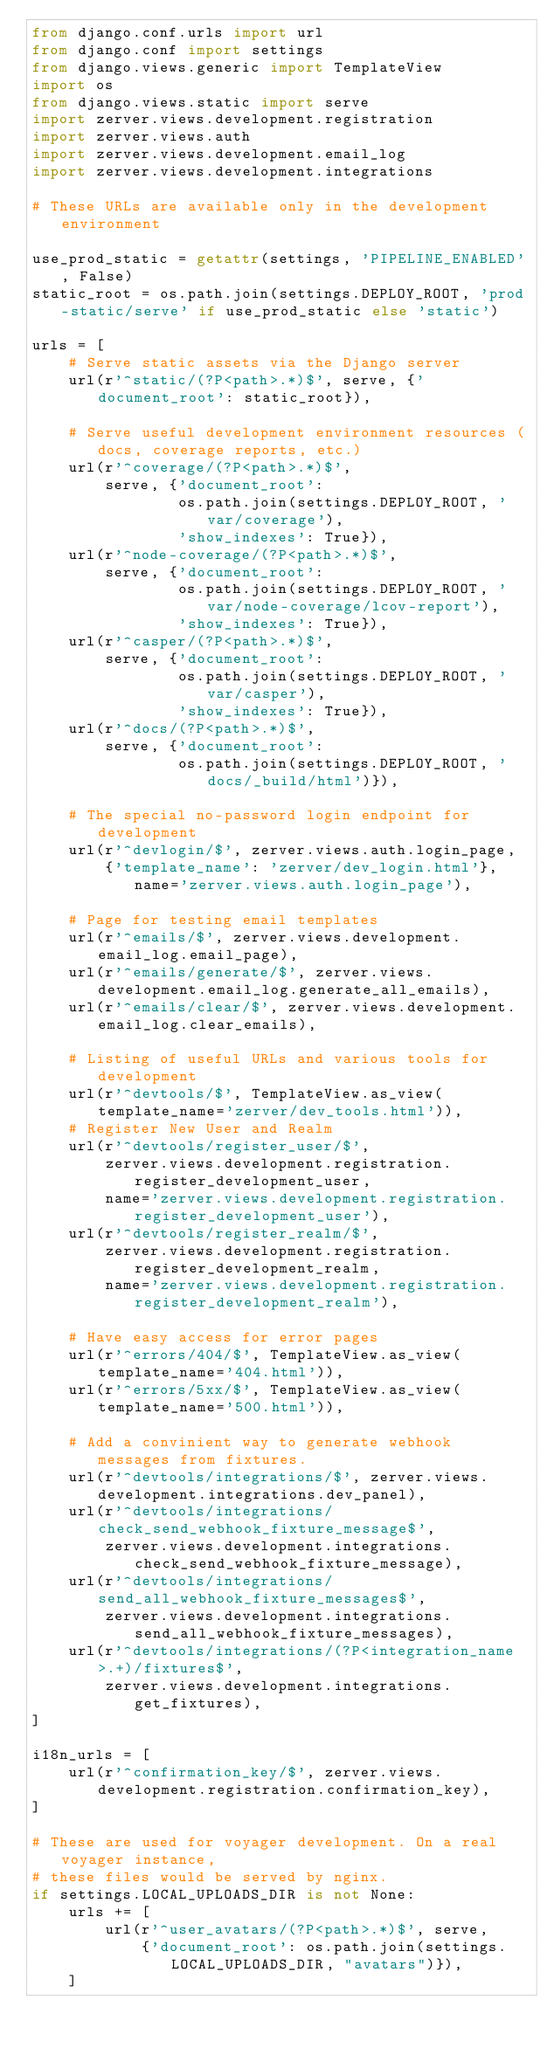Convert code to text. <code><loc_0><loc_0><loc_500><loc_500><_Python_>from django.conf.urls import url
from django.conf import settings
from django.views.generic import TemplateView
import os
from django.views.static import serve
import zerver.views.development.registration
import zerver.views.auth
import zerver.views.development.email_log
import zerver.views.development.integrations

# These URLs are available only in the development environment

use_prod_static = getattr(settings, 'PIPELINE_ENABLED', False)
static_root = os.path.join(settings.DEPLOY_ROOT, 'prod-static/serve' if use_prod_static else 'static')

urls = [
    # Serve static assets via the Django server
    url(r'^static/(?P<path>.*)$', serve, {'document_root': static_root}),

    # Serve useful development environment resources (docs, coverage reports, etc.)
    url(r'^coverage/(?P<path>.*)$',
        serve, {'document_root':
                os.path.join(settings.DEPLOY_ROOT, 'var/coverage'),
                'show_indexes': True}),
    url(r'^node-coverage/(?P<path>.*)$',
        serve, {'document_root':
                os.path.join(settings.DEPLOY_ROOT, 'var/node-coverage/lcov-report'),
                'show_indexes': True}),
    url(r'^casper/(?P<path>.*)$',
        serve, {'document_root':
                os.path.join(settings.DEPLOY_ROOT, 'var/casper'),
                'show_indexes': True}),
    url(r'^docs/(?P<path>.*)$',
        serve, {'document_root':
                os.path.join(settings.DEPLOY_ROOT, 'docs/_build/html')}),

    # The special no-password login endpoint for development
    url(r'^devlogin/$', zerver.views.auth.login_page,
        {'template_name': 'zerver/dev_login.html'}, name='zerver.views.auth.login_page'),

    # Page for testing email templates
    url(r'^emails/$', zerver.views.development.email_log.email_page),
    url(r'^emails/generate/$', zerver.views.development.email_log.generate_all_emails),
    url(r'^emails/clear/$', zerver.views.development.email_log.clear_emails),

    # Listing of useful URLs and various tools for development
    url(r'^devtools/$', TemplateView.as_view(template_name='zerver/dev_tools.html')),
    # Register New User and Realm
    url(r'^devtools/register_user/$',
        zerver.views.development.registration.register_development_user,
        name='zerver.views.development.registration.register_development_user'),
    url(r'^devtools/register_realm/$',
        zerver.views.development.registration.register_development_realm,
        name='zerver.views.development.registration.register_development_realm'),

    # Have easy access for error pages
    url(r'^errors/404/$', TemplateView.as_view(template_name='404.html')),
    url(r'^errors/5xx/$', TemplateView.as_view(template_name='500.html')),

    # Add a convinient way to generate webhook messages from fixtures.
    url(r'^devtools/integrations/$', zerver.views.development.integrations.dev_panel),
    url(r'^devtools/integrations/check_send_webhook_fixture_message$',
        zerver.views.development.integrations.check_send_webhook_fixture_message),
    url(r'^devtools/integrations/send_all_webhook_fixture_messages$',
        zerver.views.development.integrations.send_all_webhook_fixture_messages),
    url(r'^devtools/integrations/(?P<integration_name>.+)/fixtures$',
        zerver.views.development.integrations.get_fixtures),
]

i18n_urls = [
    url(r'^confirmation_key/$', zerver.views.development.registration.confirmation_key),
]

# These are used for voyager development. On a real voyager instance,
# these files would be served by nginx.
if settings.LOCAL_UPLOADS_DIR is not None:
    urls += [
        url(r'^user_avatars/(?P<path>.*)$', serve,
            {'document_root': os.path.join(settings.LOCAL_UPLOADS_DIR, "avatars")}),
    ]
</code> 